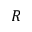<formula> <loc_0><loc_0><loc_500><loc_500>R</formula> 